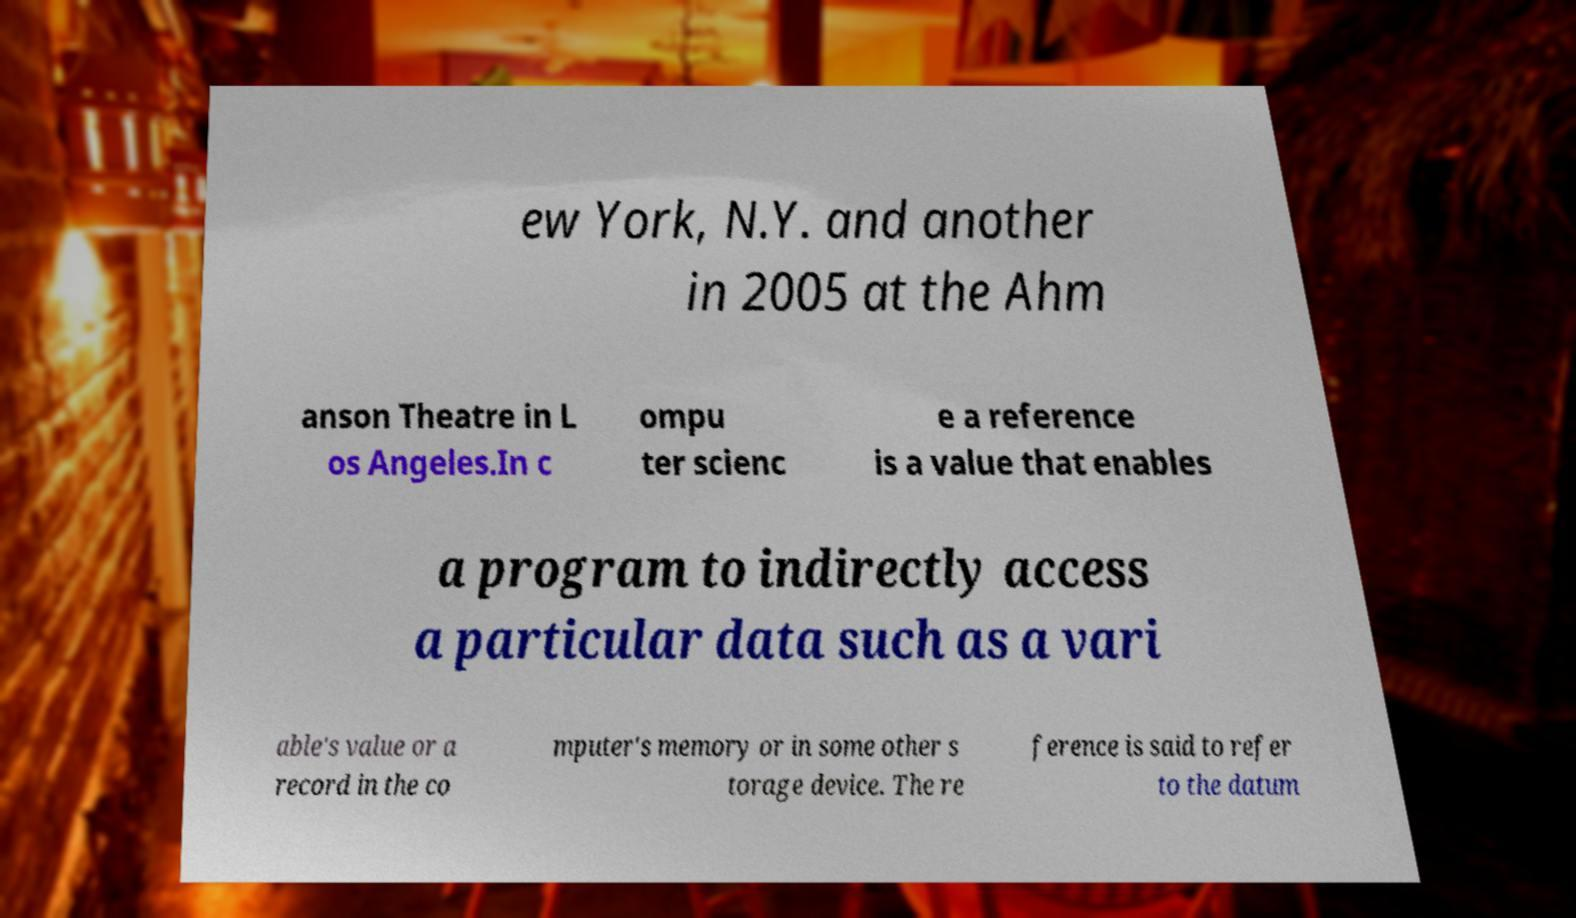Please identify and transcribe the text found in this image. ew York, N.Y. and another in 2005 at the Ahm anson Theatre in L os Angeles.In c ompu ter scienc e a reference is a value that enables a program to indirectly access a particular data such as a vari able's value or a record in the co mputer's memory or in some other s torage device. The re ference is said to refer to the datum 